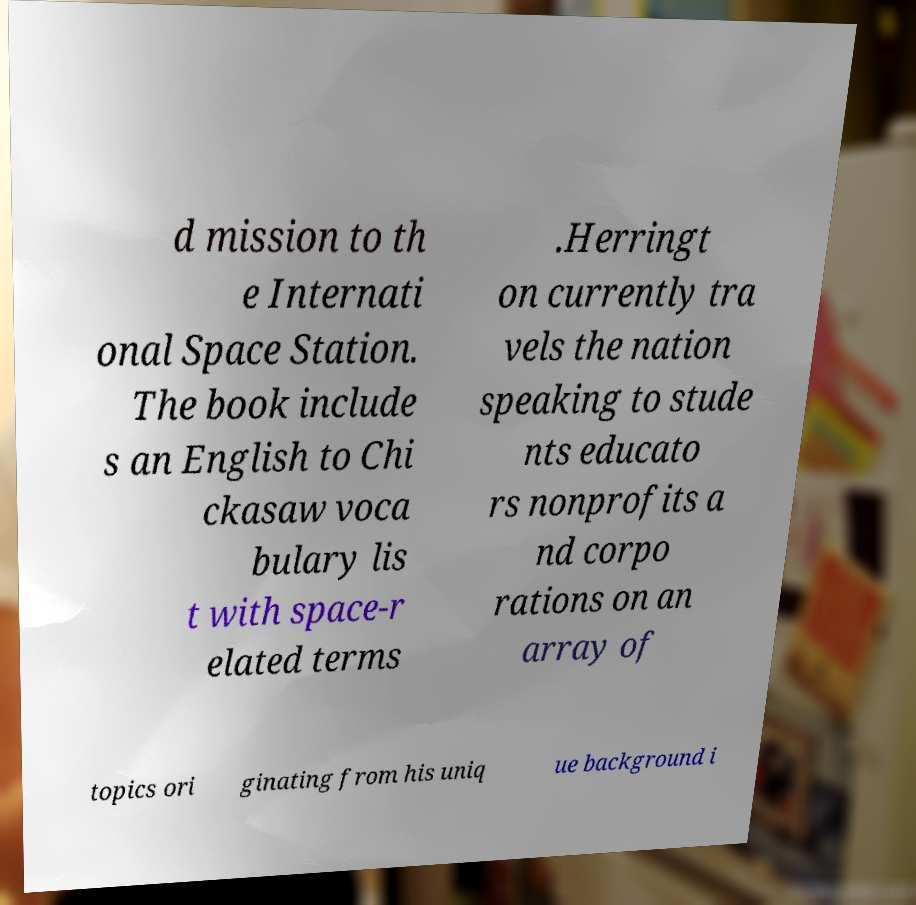There's text embedded in this image that I need extracted. Can you transcribe it verbatim? d mission to th e Internati onal Space Station. The book include s an English to Chi ckasaw voca bulary lis t with space-r elated terms .Herringt on currently tra vels the nation speaking to stude nts educato rs nonprofits a nd corpo rations on an array of topics ori ginating from his uniq ue background i 